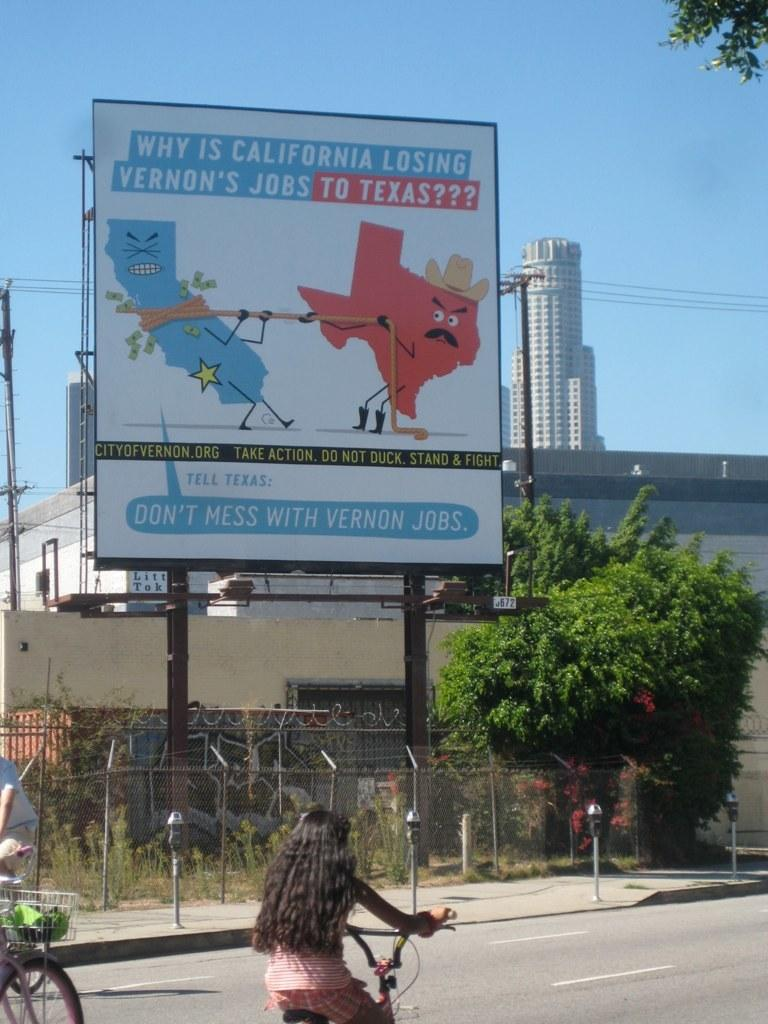<image>
Create a compact narrative representing the image presented. Two people riding their bikes past a billboard, about why California is loosing Vernon's jobs to Texas. 